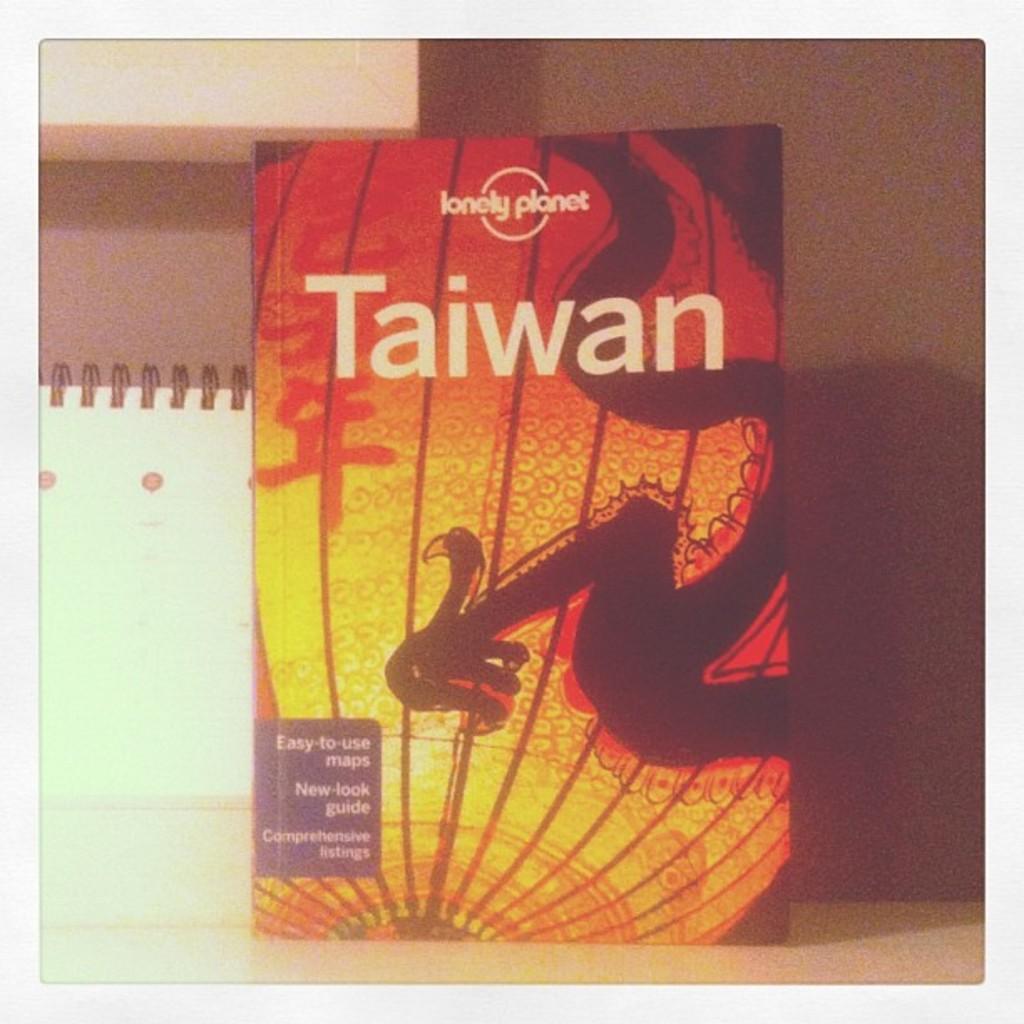Can you describe this image briefly? In this image I can see the book. In the background, I can see the wall. 